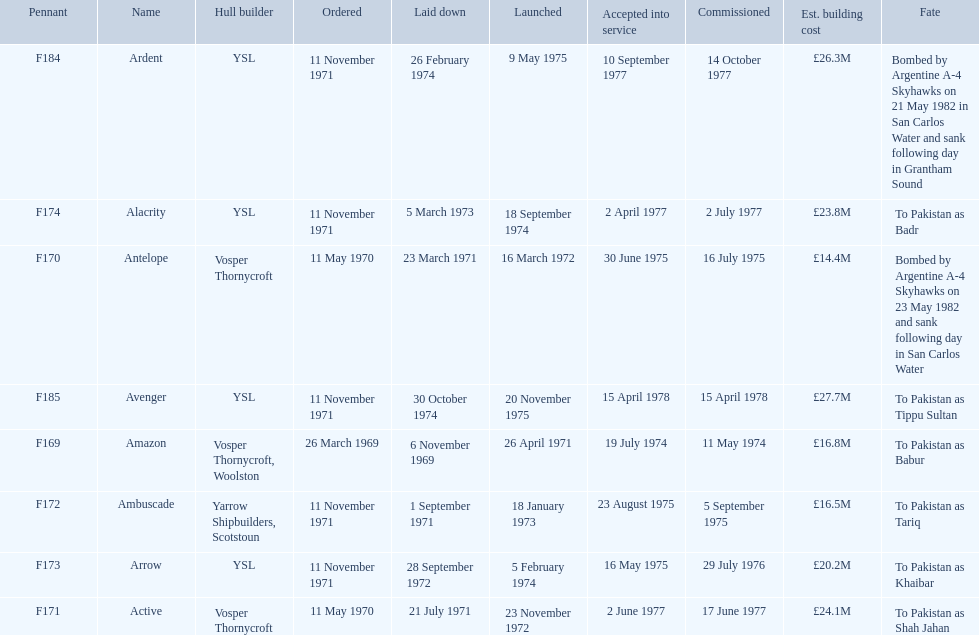Can you give me this table as a dict? {'header': ['Pennant', 'Name', 'Hull builder', 'Ordered', 'Laid down', 'Launched', 'Accepted into service', 'Commissioned', 'Est. building cost', 'Fate'], 'rows': [['F184', 'Ardent', 'YSL', '11 November 1971', '26 February 1974', '9 May 1975', '10 September 1977', '14 October 1977', '£26.3M', 'Bombed by Argentine A-4 Skyhawks on 21 May 1982 in San Carlos Water and sank following day in Grantham Sound'], ['F174', 'Alacrity', 'YSL', '11 November 1971', '5 March 1973', '18 September 1974', '2 April 1977', '2 July 1977', '£23.8M', 'To Pakistan as Badr'], ['F170', 'Antelope', 'Vosper Thornycroft', '11 May 1970', '23 March 1971', '16 March 1972', '30 June 1975', '16 July 1975', '£14.4M', 'Bombed by Argentine A-4 Skyhawks on 23 May 1982 and sank following day in San Carlos Water'], ['F185', 'Avenger', 'YSL', '11 November 1971', '30 October 1974', '20 November 1975', '15 April 1978', '15 April 1978', '£27.7M', 'To Pakistan as Tippu Sultan'], ['F169', 'Amazon', 'Vosper Thornycroft, Woolston', '26 March 1969', '6 November 1969', '26 April 1971', '19 July 1974', '11 May 1974', '£16.8M', 'To Pakistan as Babur'], ['F172', 'Ambuscade', 'Yarrow Shipbuilders, Scotstoun', '11 November 1971', '1 September 1971', '18 January 1973', '23 August 1975', '5 September 1975', '£16.5M', 'To Pakistan as Tariq'], ['F173', 'Arrow', 'YSL', '11 November 1971', '28 September 1972', '5 February 1974', '16 May 1975', '29 July 1976', '£20.2M', 'To Pakistan as Khaibar'], ['F171', 'Active', 'Vosper Thornycroft', '11 May 1970', '21 July 1971', '23 November 1972', '2 June 1977', '17 June 1977', '£24.1M', 'To Pakistan as Shah Jahan']]} What is the next pennant after f172? F173. 